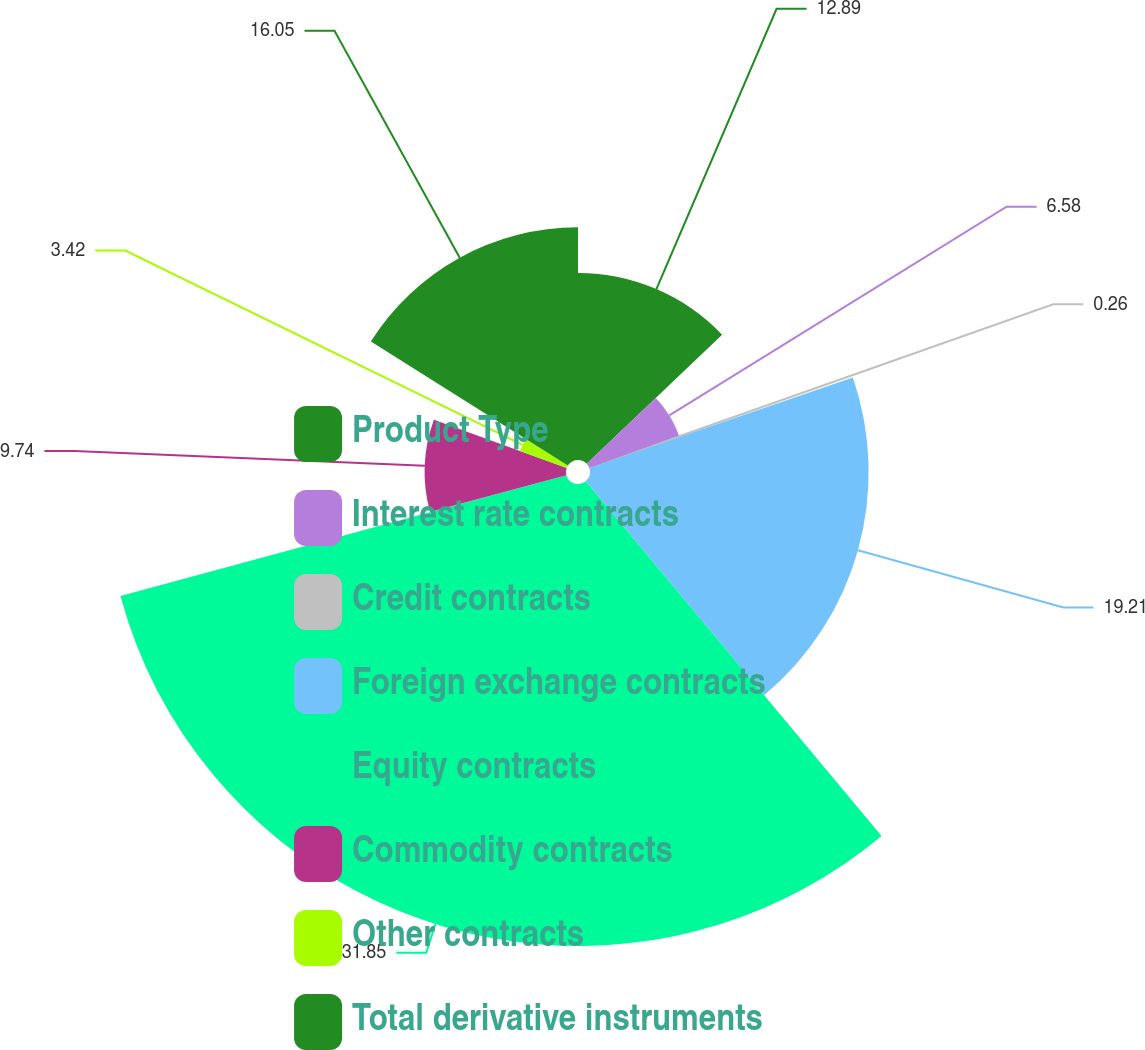Convert chart to OTSL. <chart><loc_0><loc_0><loc_500><loc_500><pie_chart><fcel>Product Type<fcel>Interest rate contracts<fcel>Credit contracts<fcel>Foreign exchange contracts<fcel>Equity contracts<fcel>Commodity contracts<fcel>Other contracts<fcel>Total derivative instruments<nl><fcel>12.89%<fcel>6.58%<fcel>0.26%<fcel>19.21%<fcel>31.85%<fcel>9.74%<fcel>3.42%<fcel>16.05%<nl></chart> 